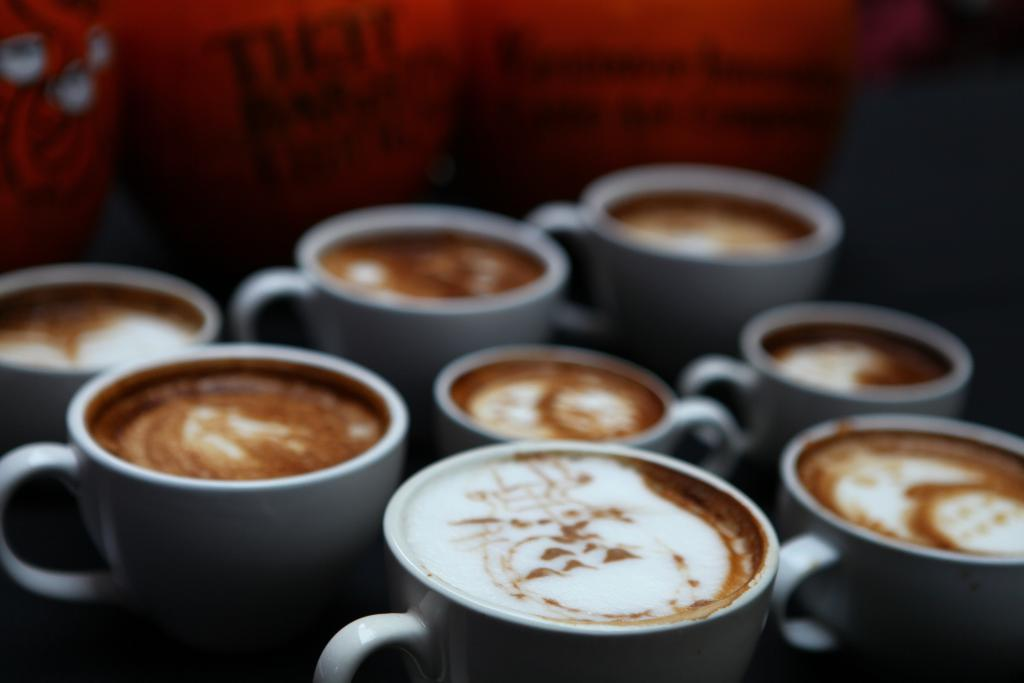What is in the cups that are visible in the image? There are cups of coffee in the image. Can you describe the background of the image? The background of the image is blurry. What color is the unidentified object in the background of the image? The unidentified object in the background of the image is red. What type of ice can be seen melting on the ground in the image? There is no ice or ground visible in the image; it only features cups of coffee and a blurry background. 